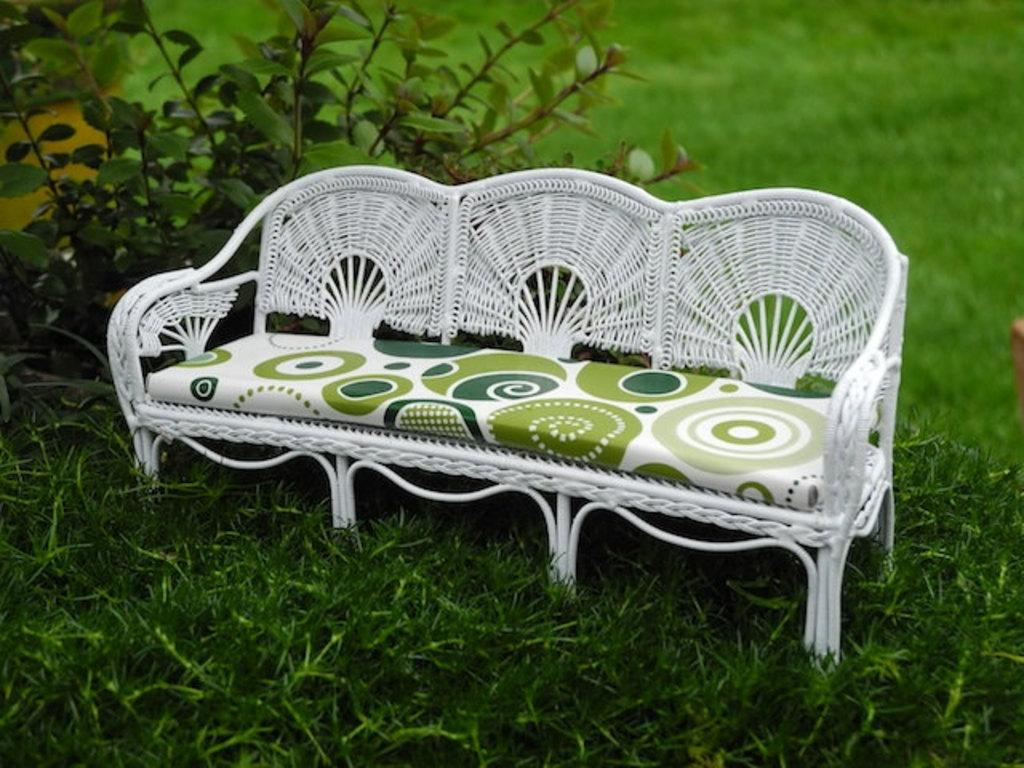What type of seating is present in the image? There is a bench in the image. Where is the bench located? The bench is placed on the ground. What is located beside the bench? There is a plant beside the bench. What can be seen on the ground in the image? The ground is visible in the image, and there is grass on the ground. What type of song is being sung by the plant in the image? There is no indication in the image that the plant is singing a song, as plants do not have the ability to sing. 